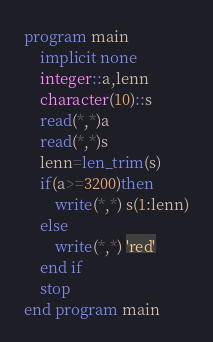Convert code to text. <code><loc_0><loc_0><loc_500><loc_500><_FORTRAN_>program main
	implicit none
    integer::a,lenn
    character(10)::s
    read(*,*)a
    read(*,*)s
    lenn=len_trim(s)
    if(a>=3200)then
    	write(*,*) s(1:lenn)
    else
    	write(*,*) 'red'
    end if
    stop
end program main

</code> 